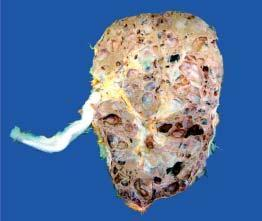what is enlarged and heavy?
Answer the question using a single word or phrase. Kidney 